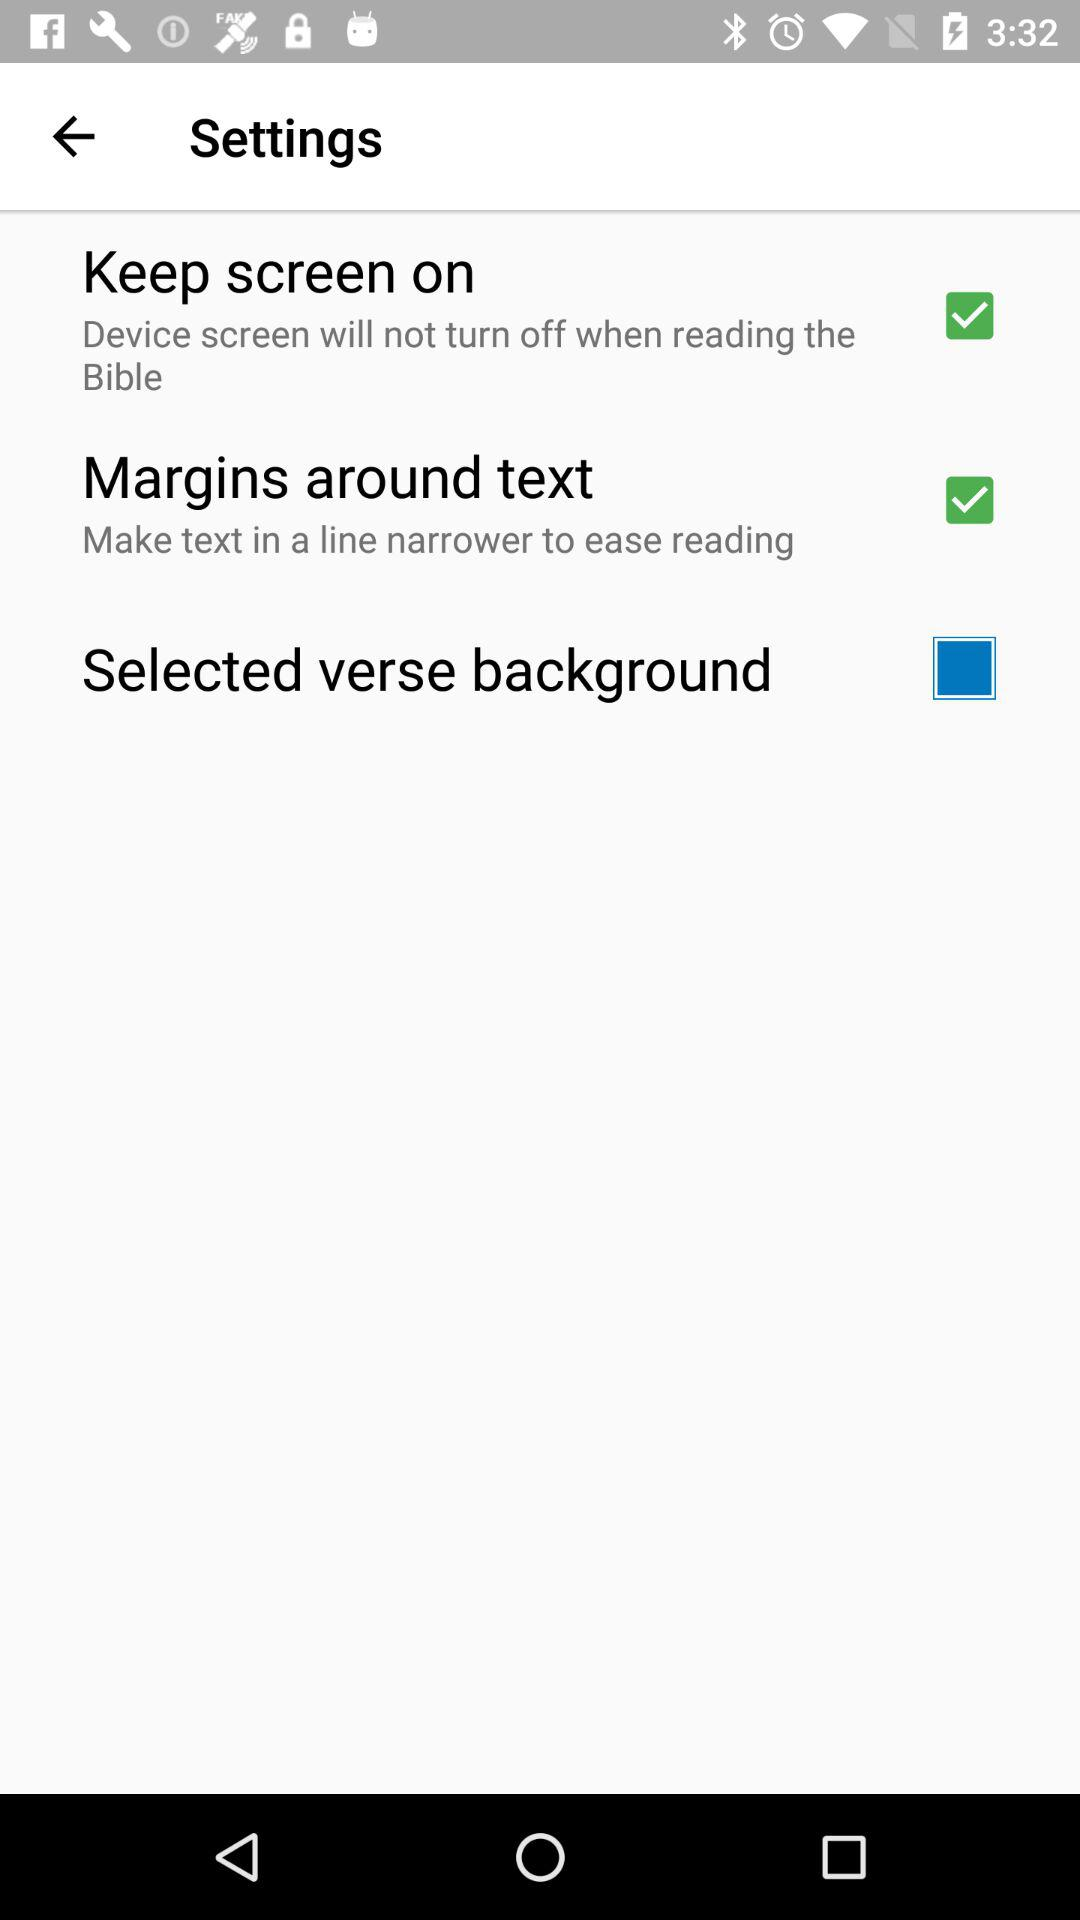How many settings can be enabled or disabled?
Answer the question using a single word or phrase. 3 